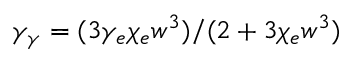<formula> <loc_0><loc_0><loc_500><loc_500>\gamma _ { \gamma } = ( 3 \gamma _ { e } \chi _ { e } w ^ { 3 } ) / ( 2 + 3 \chi _ { e } w ^ { 3 } )</formula> 